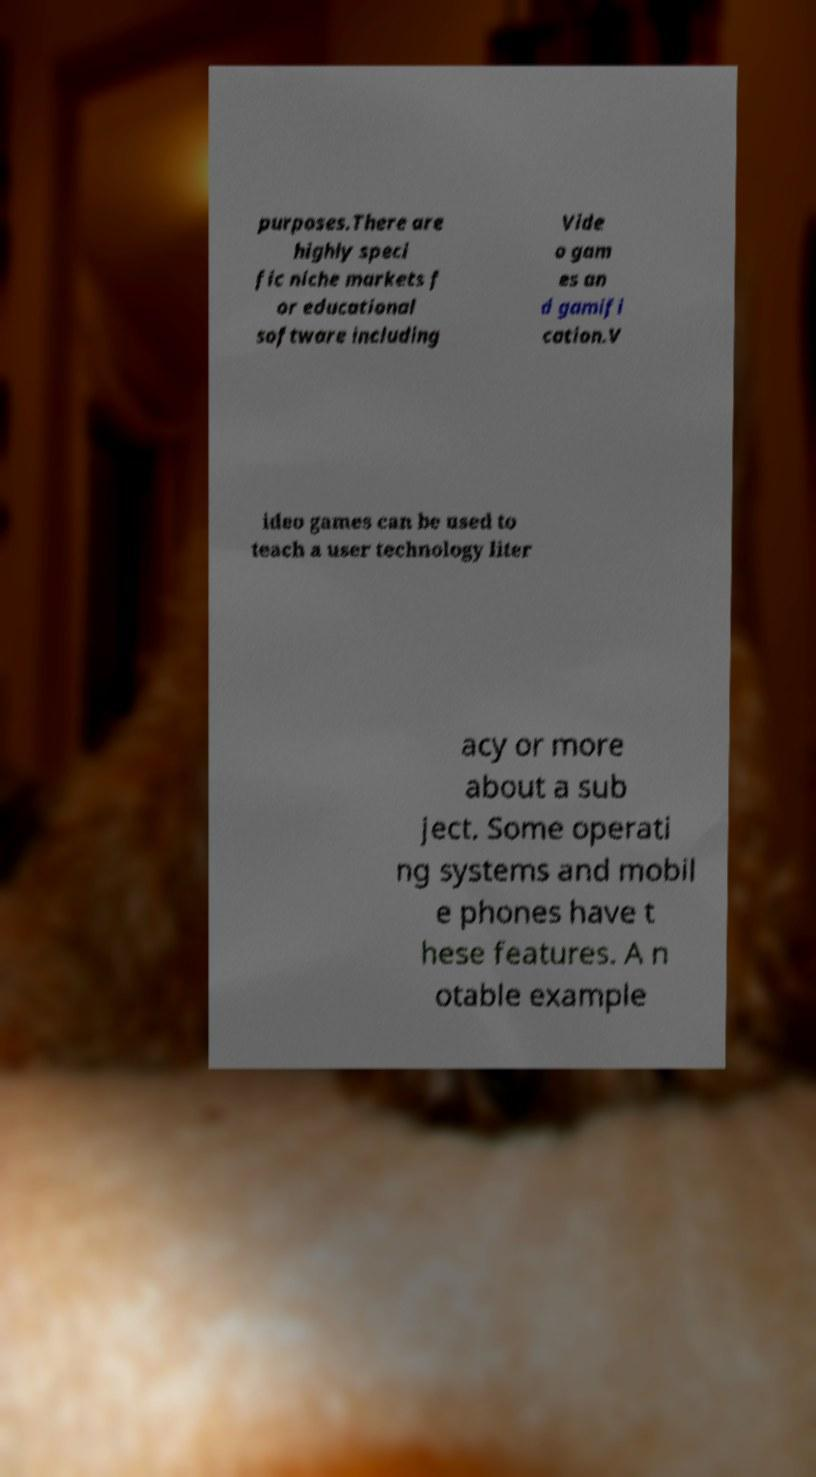Please read and relay the text visible in this image. What does it say? purposes.There are highly speci fic niche markets f or educational software including Vide o gam es an d gamifi cation.V ideo games can be used to teach a user technology liter acy or more about a sub ject. Some operati ng systems and mobil e phones have t hese features. A n otable example 